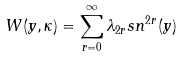Convert formula to latex. <formula><loc_0><loc_0><loc_500><loc_500>W ( y , \kappa ) = \sum ^ { \infty } _ { r = 0 } \lambda _ { 2 r } s n ^ { 2 r } ( y )</formula> 